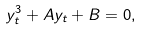<formula> <loc_0><loc_0><loc_500><loc_500>y _ { t } ^ { 3 } + A y _ { t } + B = 0 ,</formula> 